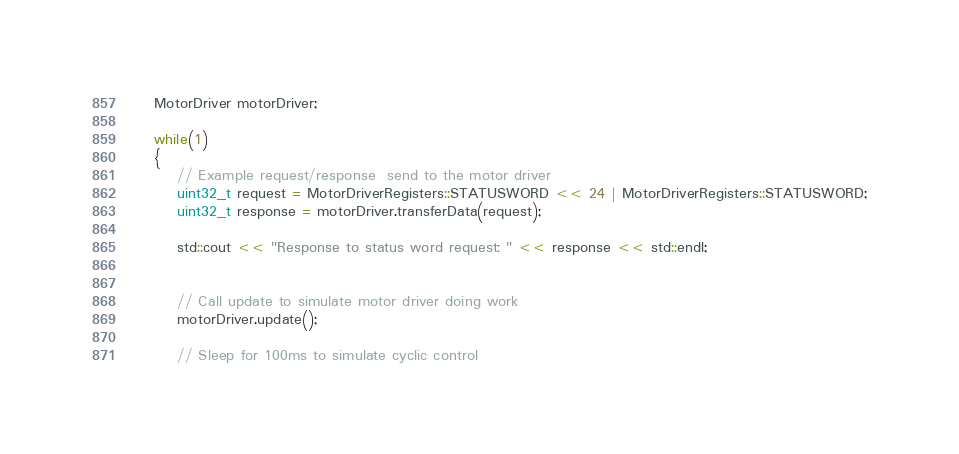Convert code to text. <code><loc_0><loc_0><loc_500><loc_500><_C++_>
    MotorDriver motorDriver;

    while(1)
    {
        // Example request/response  send to the motor driver
        uint32_t request = MotorDriverRegisters::STATUSWORD << 24 | MotorDriverRegisters::STATUSWORD;
        uint32_t response = motorDriver.transferData(request);

        std::cout << "Response to status word request: " << response << std::endl;


        // Call update to simulate motor driver doing work
        motorDriver.update();

        // Sleep for 100ms to simulate cyclic control</code> 